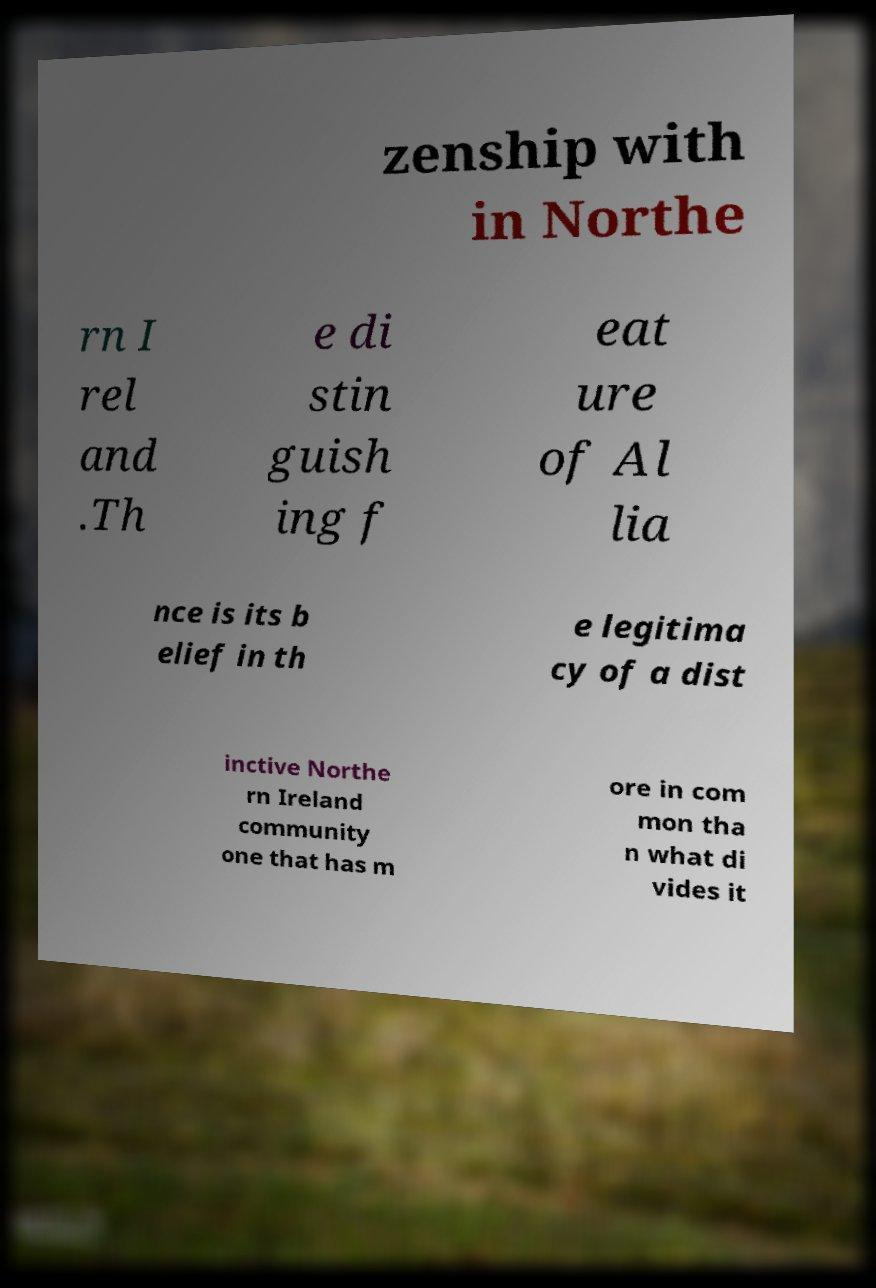Can you read and provide the text displayed in the image?This photo seems to have some interesting text. Can you extract and type it out for me? zenship with in Northe rn I rel and .Th e di stin guish ing f eat ure of Al lia nce is its b elief in th e legitima cy of a dist inctive Northe rn Ireland community one that has m ore in com mon tha n what di vides it 